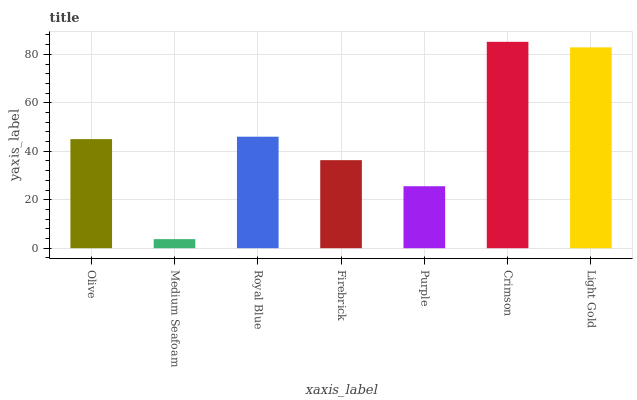Is Medium Seafoam the minimum?
Answer yes or no. Yes. Is Crimson the maximum?
Answer yes or no. Yes. Is Royal Blue the minimum?
Answer yes or no. No. Is Royal Blue the maximum?
Answer yes or no. No. Is Royal Blue greater than Medium Seafoam?
Answer yes or no. Yes. Is Medium Seafoam less than Royal Blue?
Answer yes or no. Yes. Is Medium Seafoam greater than Royal Blue?
Answer yes or no. No. Is Royal Blue less than Medium Seafoam?
Answer yes or no. No. Is Olive the high median?
Answer yes or no. Yes. Is Olive the low median?
Answer yes or no. Yes. Is Crimson the high median?
Answer yes or no. No. Is Purple the low median?
Answer yes or no. No. 